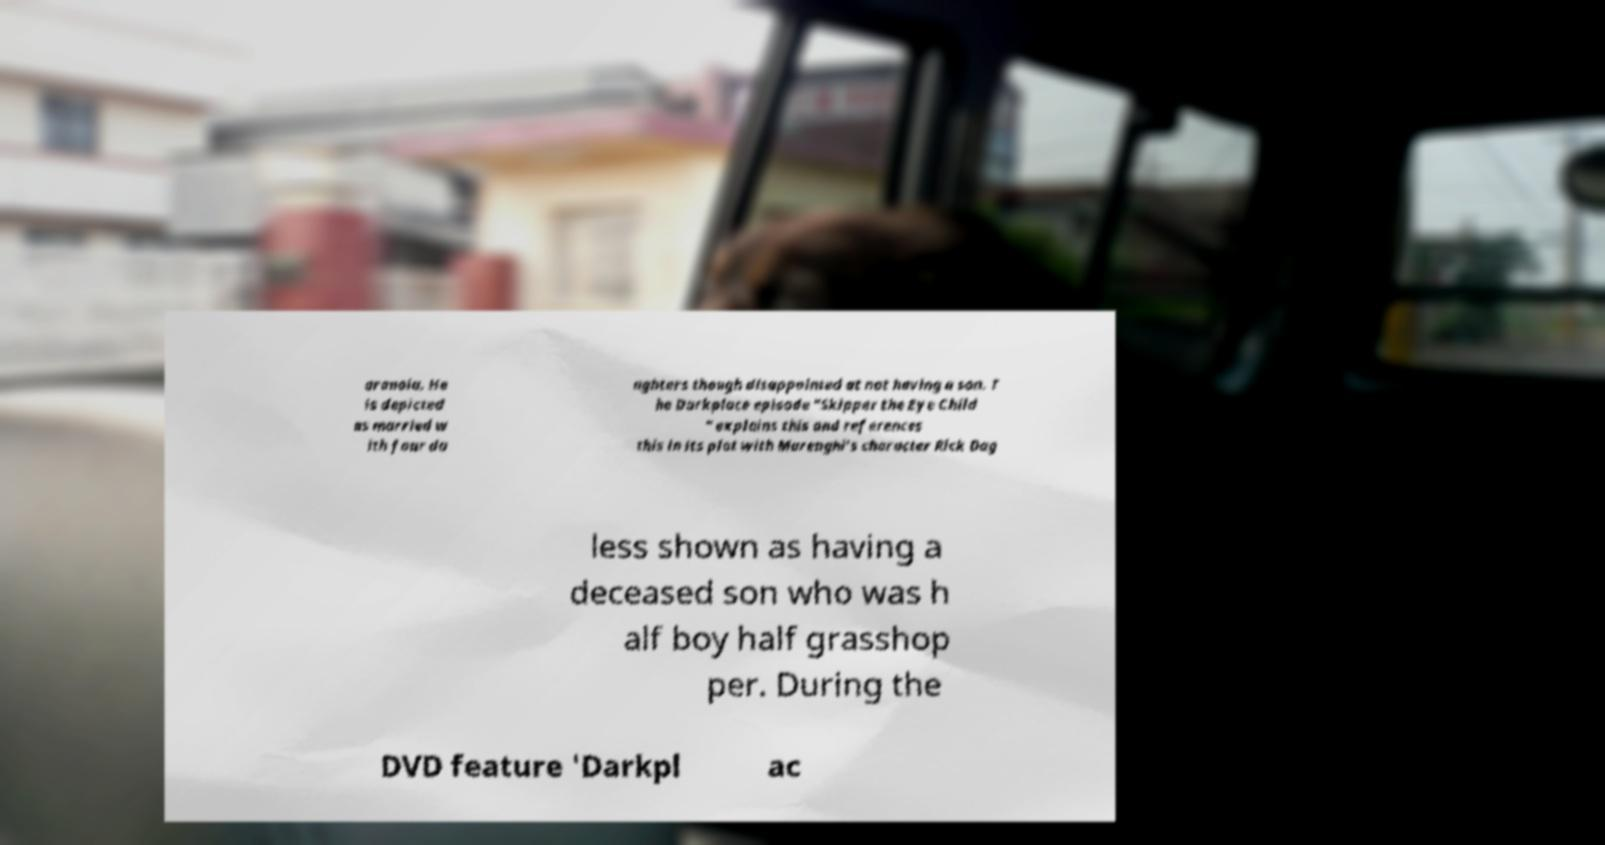There's text embedded in this image that I need extracted. Can you transcribe it verbatim? aranoia. He is depicted as married w ith four da ughters though disappointed at not having a son. T he Darkplace episode "Skipper the Eye Child " explains this and references this in its plot with Marenghi's character Rick Dag less shown as having a deceased son who was h alf boy half grasshop per. During the DVD feature 'Darkpl ac 